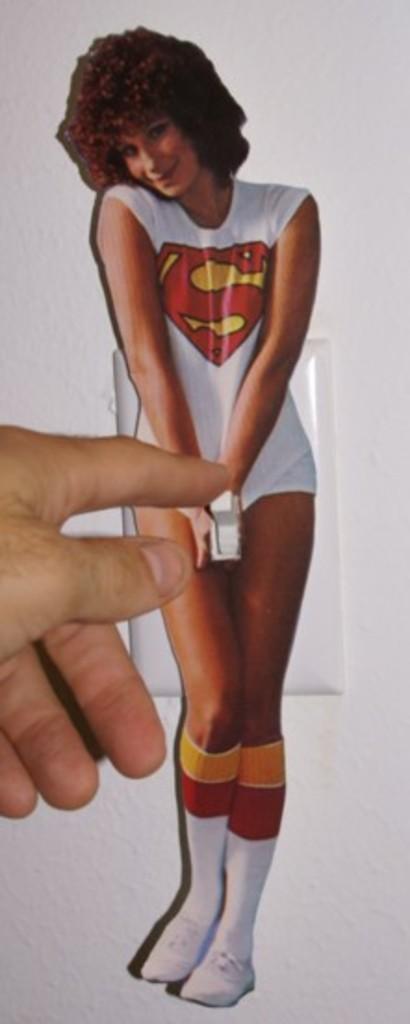How would you summarize this image in a sentence or two? In this picture we can see a person hand, sticker of a woman on a switchboard and in the background we can see the wall. 